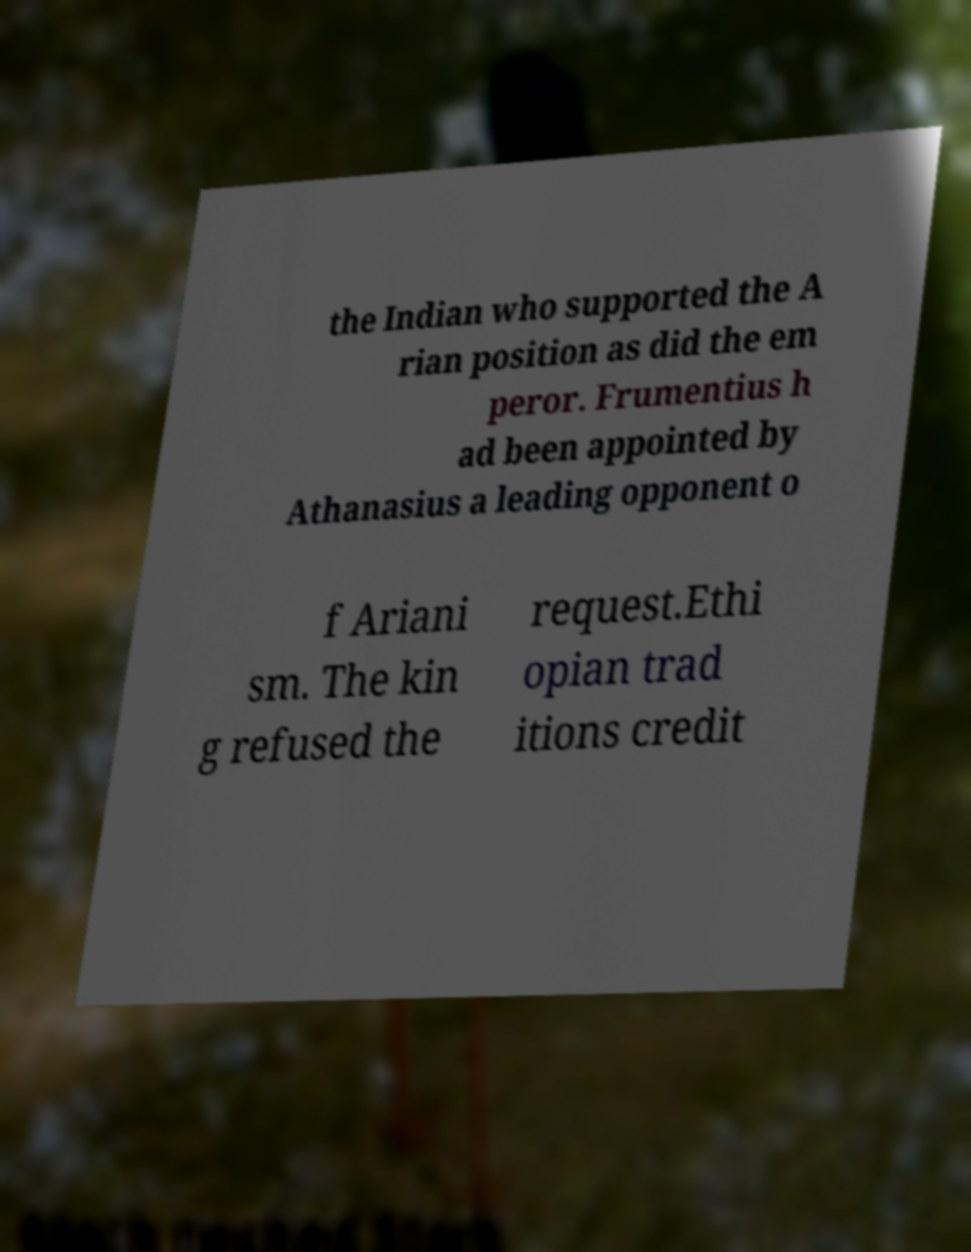Can you accurately transcribe the text from the provided image for me? the Indian who supported the A rian position as did the em peror. Frumentius h ad been appointed by Athanasius a leading opponent o f Ariani sm. The kin g refused the request.Ethi opian trad itions credit 